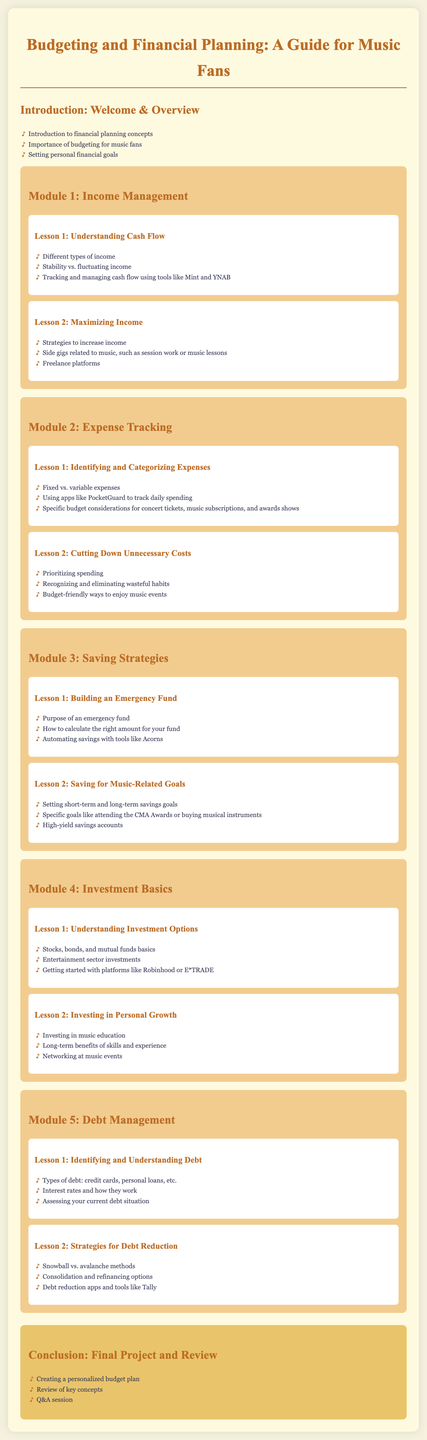What is the title of the syllabus? The title is the main heading of the document and is stated at the top.
Answer: Budgeting and Financial Planning: A Guide for Music Fans What is the primary focus of Module 1? Module 1 covers topics related to managing income, including cash flow.
Answer: Income Management What is one tool mentioned for tracking cash flow? The lesson discusses tools that can assist in managing cash flow.
Answer: Mint What are the two types of expenses discussed in Module 2? This lesson categorizes expenses for better budgeting.
Answer: Fixed and variable expenses What is one strategy to increase income mentioned in Module 1? The lesson provides various strategies for handling income effectively.
Answer: Side gigs What is the purpose of an emergency fund as outlined in Module 3? The lesson elaborates on the significance of having a financial buffer.
Answer: Purpose of an emergency fund What is one investment platform mentioned in Module 4? The lesson discusses various platforms for starting investments.
Answer: Robinhood What are the two methods for debt reduction discussed in Module 5? This lesson covers strategies for effectively managing debt.
Answer: Snowball and avalanche methods What is the main task to complete in the conclusion? The final section emphasizes creating a personal financial document.
Answer: Creating a personalized budget plan 